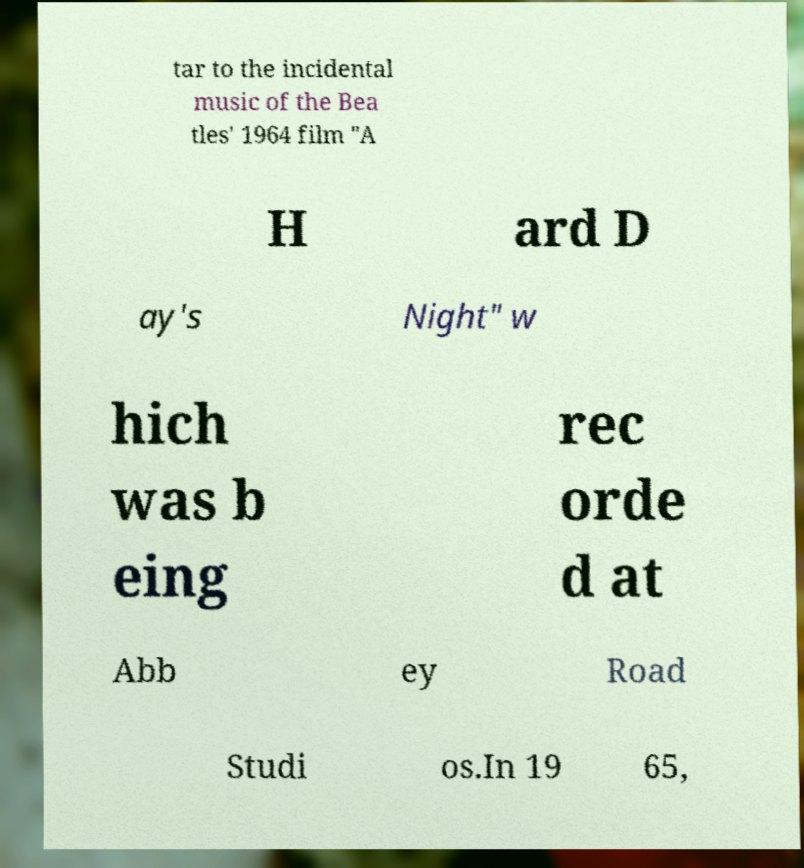I need the written content from this picture converted into text. Can you do that? tar to the incidental music of the Bea tles' 1964 film "A H ard D ay's Night" w hich was b eing rec orde d at Abb ey Road Studi os.In 19 65, 